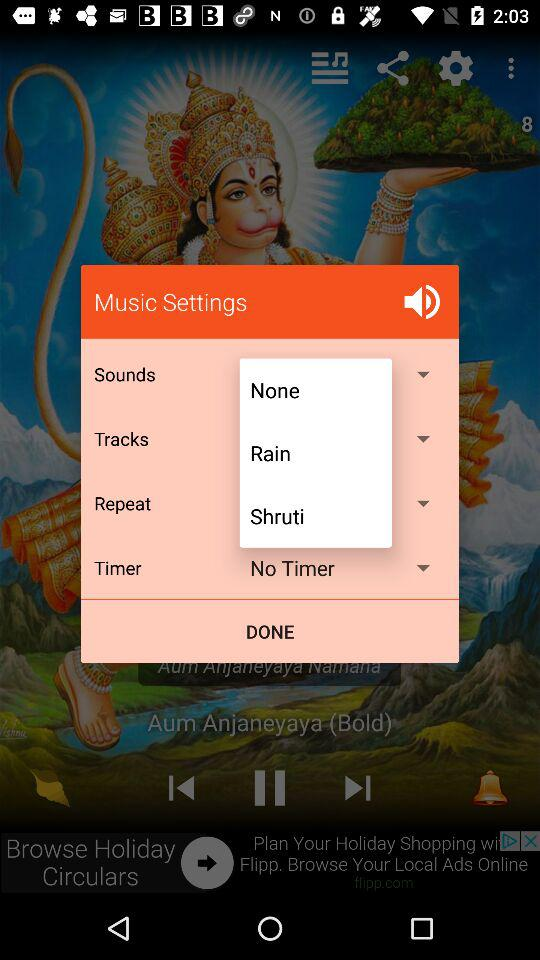Which is the selected timer? The selected timer is "No timer". 